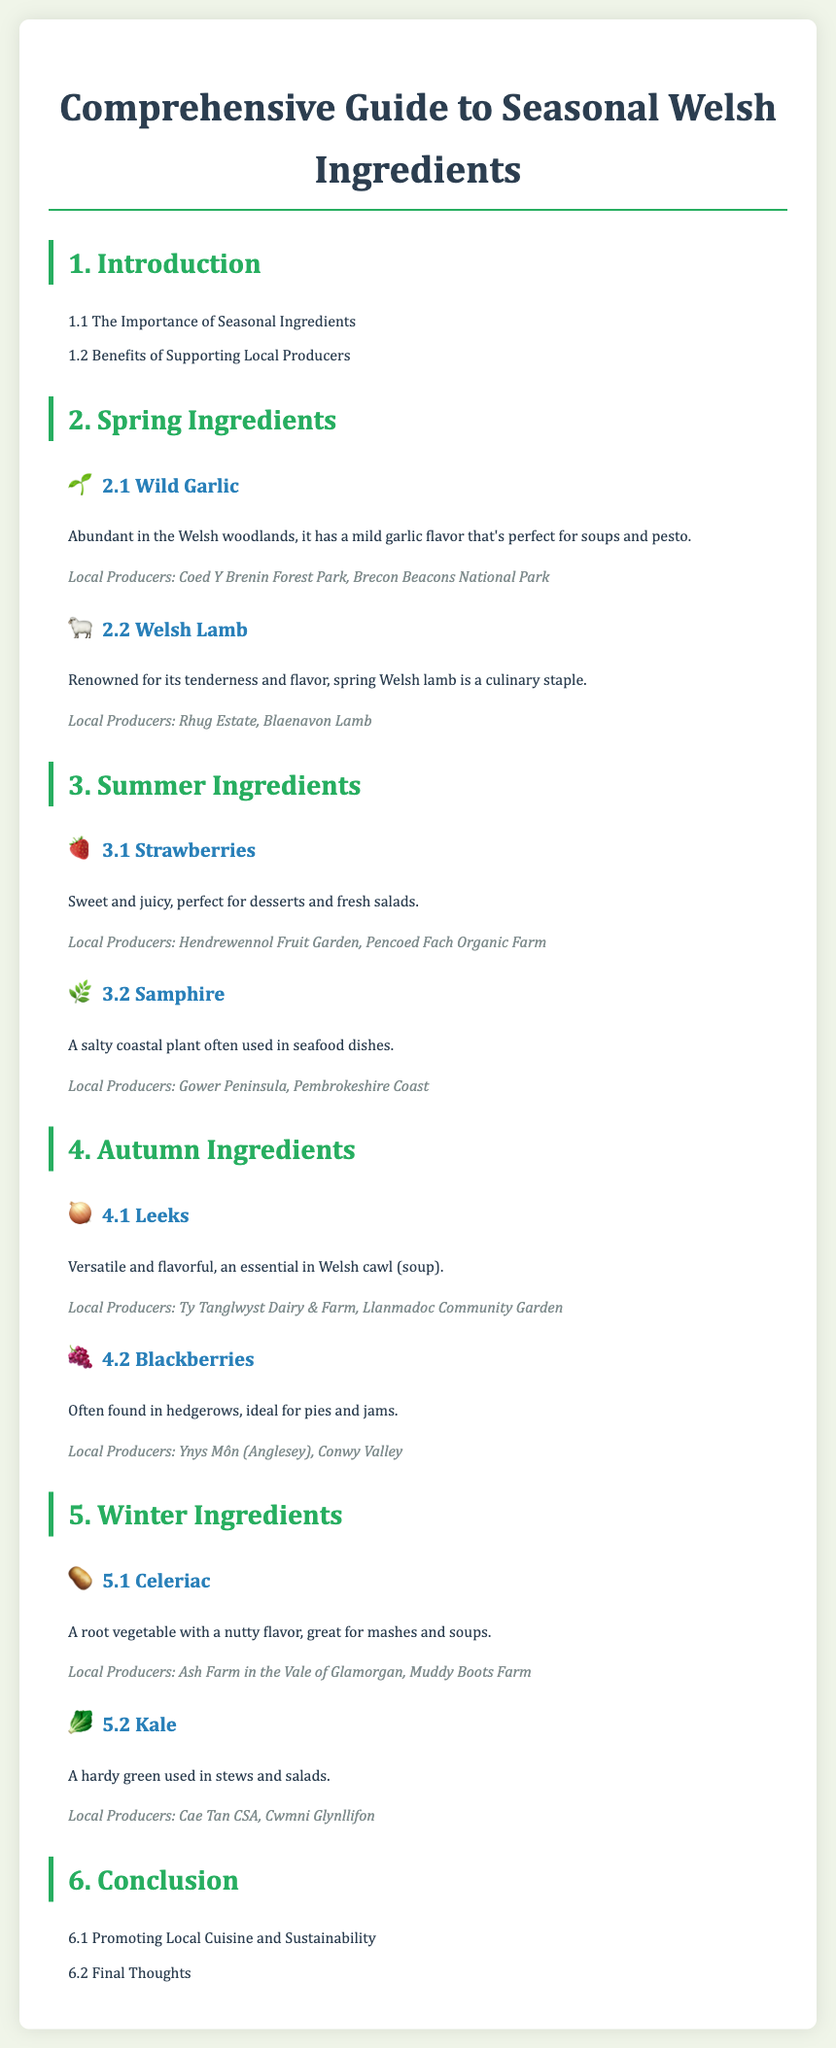What is the title of this document? The title of the document is presented in the header section, emphasizing the focus on Welsh ingredients.
Answer: Comprehensive Guide to Seasonal Welsh Ingredients How many seasonal ingredient sections are there? The document lists four distinct seasons, each with its own section for ingredients.
Answer: Four Which spring ingredient is known for its use in soups and pesto? The description under spring ingredients highlights the culinary uses of this particular ingredient.
Answer: Wild Garlic What is a common autumn ingredient used in Welsh cawl? The content specifies this ingredient as versatile and essential for a traditional Welsh dish.
Answer: Leeks Which local producer is associated with Strawberries? The document mentions specific producers listed under the summer ingredients category.
Answer: Hendrewennol Fruit Garden What is the theme of the conclusion section? The conclusion focuses on broader implications regarding local cuisine and environmental considerations.
Answer: Promoting Local Cuisine and Sustainability Which summer ingredient is described as a coastal plant? The document specifically categorizes this ingredient, highlighting its unique habitat and culinary application.
Answer: Samphire What type of farms are mentioned as producers for Kale? The text lists specific types of producers associated with this ingredient.
Answer: Cae Tan CSA What icon represents winter ingredients in the document? Each seasonal section has a unique icon to visually represent its theme, particularly in the winter section.
Answer: 🥔 